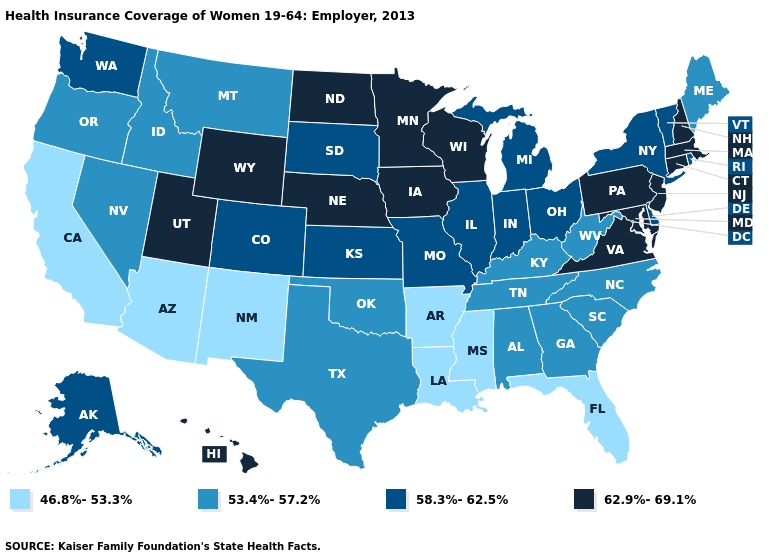What is the lowest value in states that border California?
Keep it brief. 46.8%-53.3%. Among the states that border Vermont , does New York have the lowest value?
Answer briefly. Yes. Which states have the highest value in the USA?
Give a very brief answer. Connecticut, Hawaii, Iowa, Maryland, Massachusetts, Minnesota, Nebraska, New Hampshire, New Jersey, North Dakota, Pennsylvania, Utah, Virginia, Wisconsin, Wyoming. Which states have the lowest value in the South?
Write a very short answer. Arkansas, Florida, Louisiana, Mississippi. What is the value of Louisiana?
Concise answer only. 46.8%-53.3%. What is the lowest value in the USA?
Keep it brief. 46.8%-53.3%. Which states have the lowest value in the West?
Answer briefly. Arizona, California, New Mexico. Which states have the lowest value in the USA?
Quick response, please. Arizona, Arkansas, California, Florida, Louisiana, Mississippi, New Mexico. Does New Mexico have a higher value than Michigan?
Short answer required. No. What is the highest value in the Northeast ?
Answer briefly. 62.9%-69.1%. Among the states that border Colorado , which have the highest value?
Answer briefly. Nebraska, Utah, Wyoming. What is the value of Michigan?
Be succinct. 58.3%-62.5%. What is the value of Vermont?
Write a very short answer. 58.3%-62.5%. Name the states that have a value in the range 46.8%-53.3%?
Keep it brief. Arizona, Arkansas, California, Florida, Louisiana, Mississippi, New Mexico. Does the map have missing data?
Concise answer only. No. 